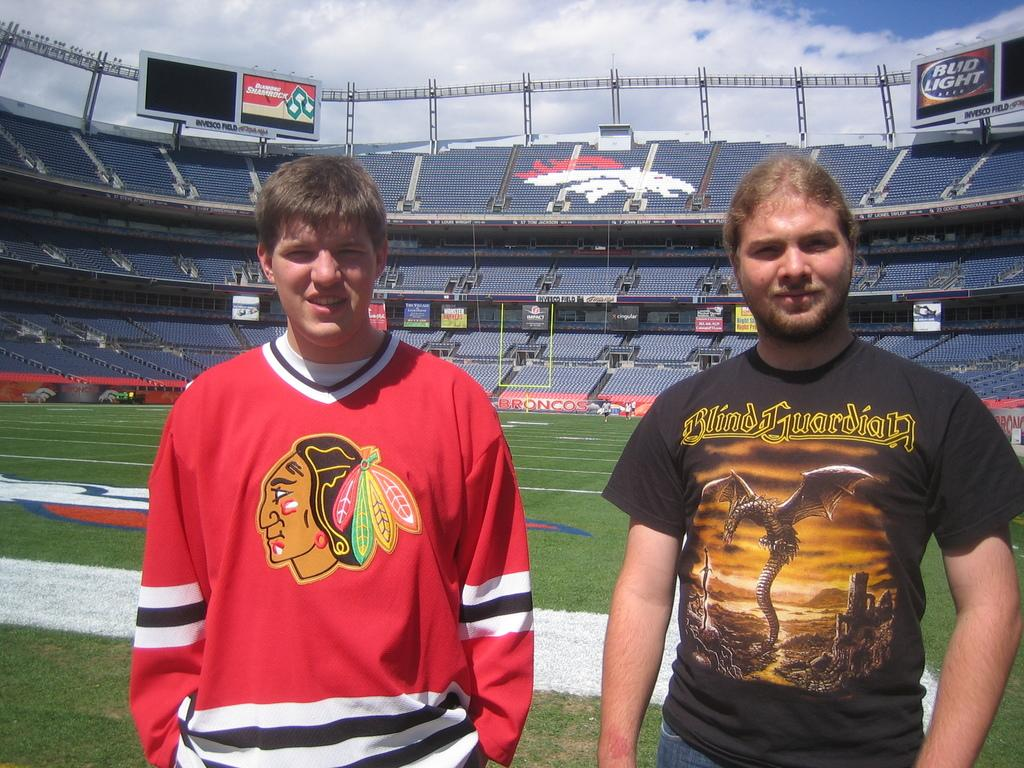<image>
Describe the image concisely. Two men stand on an empty stadium field, one wearing a shirt that says Blind Guardian 